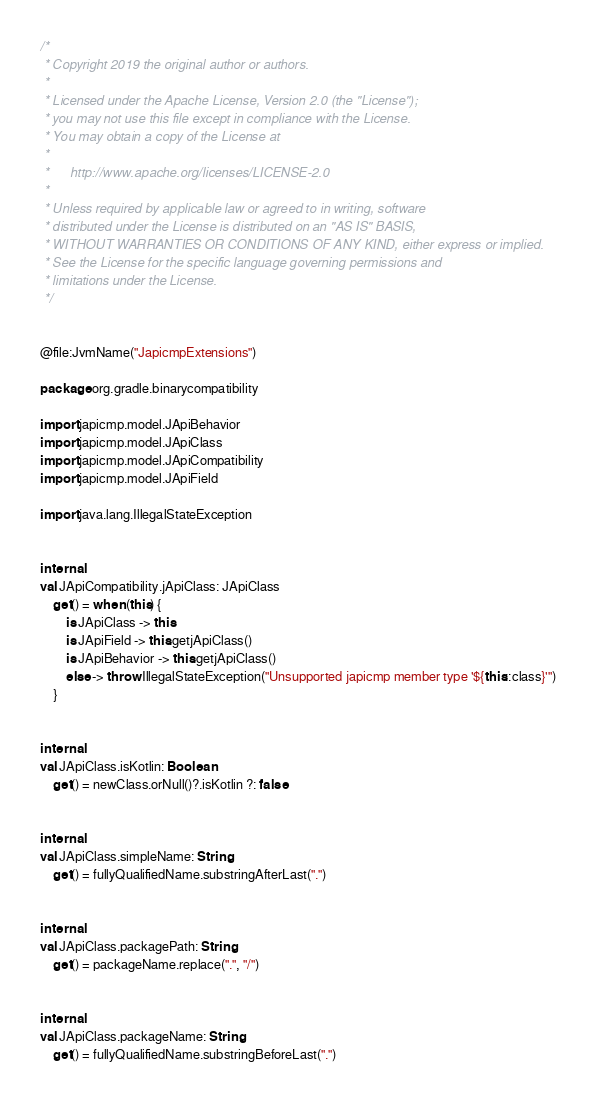<code> <loc_0><loc_0><loc_500><loc_500><_Kotlin_>/*
 * Copyright 2019 the original author or authors.
 *
 * Licensed under the Apache License, Version 2.0 (the "License");
 * you may not use this file except in compliance with the License.
 * You may obtain a copy of the License at
 *
 *      http://www.apache.org/licenses/LICENSE-2.0
 *
 * Unless required by applicable law or agreed to in writing, software
 * distributed under the License is distributed on an "AS IS" BASIS,
 * WITHOUT WARRANTIES OR CONDITIONS OF ANY KIND, either express or implied.
 * See the License for the specific language governing permissions and
 * limitations under the License.
 */


@file:JvmName("JapicmpExtensions")

package org.gradle.binarycompatibility

import japicmp.model.JApiBehavior
import japicmp.model.JApiClass
import japicmp.model.JApiCompatibility
import japicmp.model.JApiField

import java.lang.IllegalStateException


internal
val JApiCompatibility.jApiClass: JApiClass
    get() = when (this) {
        is JApiClass -> this
        is JApiField -> this.getjApiClass()
        is JApiBehavior -> this.getjApiClass()
        else -> throw IllegalStateException("Unsupported japicmp member type '${this::class}'")
    }


internal
val JApiClass.isKotlin: Boolean
    get() = newClass.orNull()?.isKotlin ?: false


internal
val JApiClass.simpleName: String
    get() = fullyQualifiedName.substringAfterLast(".")


internal
val JApiClass.packagePath: String
    get() = packageName.replace(".", "/")


internal
val JApiClass.packageName: String
    get() = fullyQualifiedName.substringBeforeLast(".")
</code> 